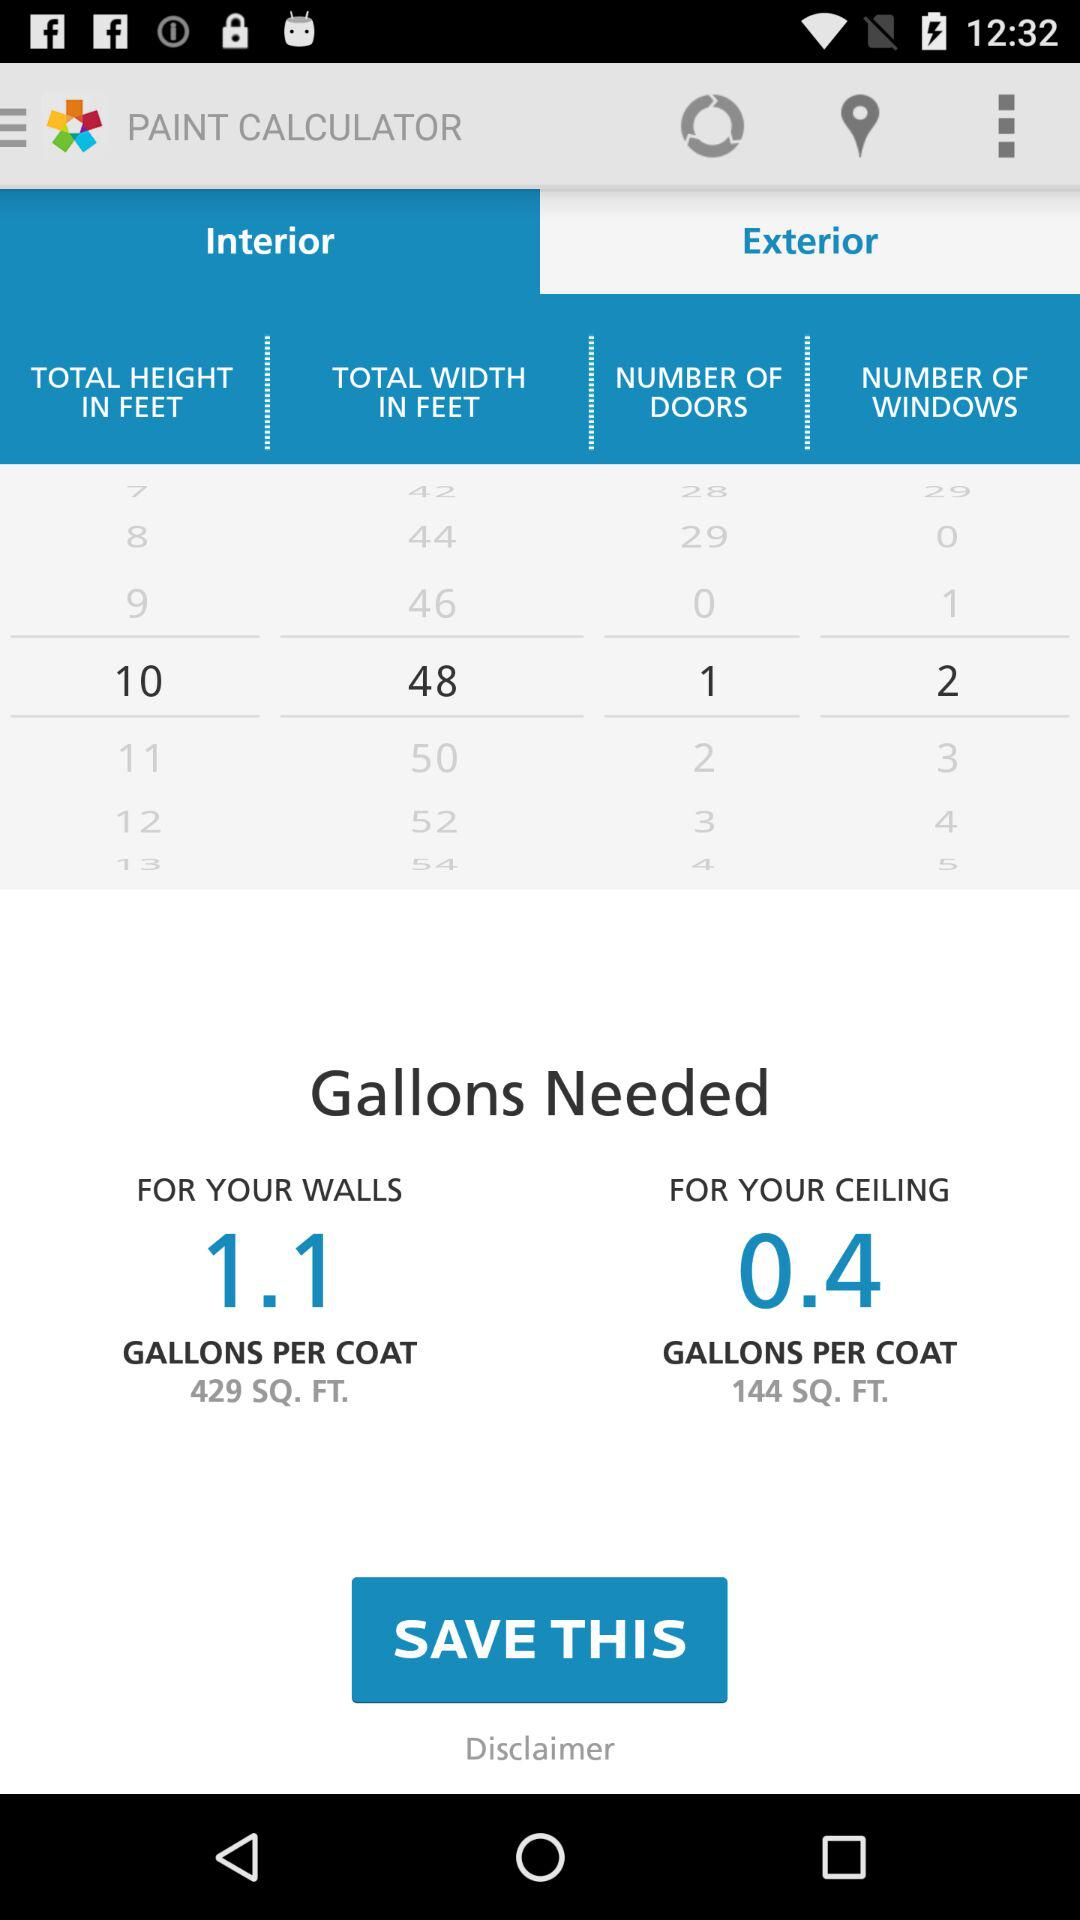How many more square feet are needed to paint the ceilings than the walls?
Answer the question using a single word or phrase. 285 